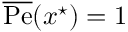Convert formula to latex. <formula><loc_0><loc_0><loc_500><loc_500>\overline { P e } ( x ^ { ^ { * } } ) = 1</formula> 